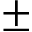Convert formula to latex. <formula><loc_0><loc_0><loc_500><loc_500>\pm</formula> 